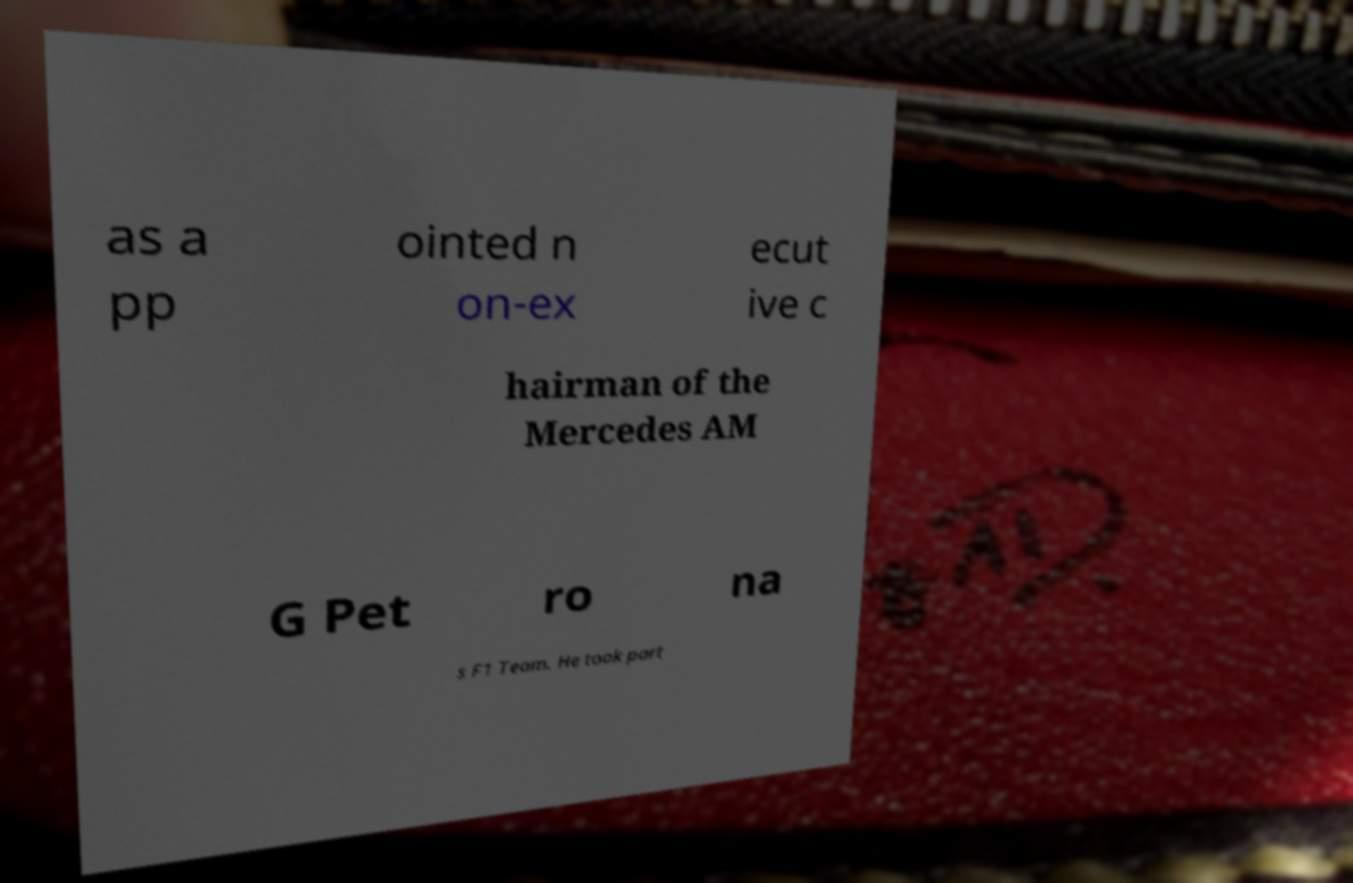Please read and relay the text visible in this image. What does it say? as a pp ointed n on-ex ecut ive c hairman of the Mercedes AM G Pet ro na s F1 Team. He took part 